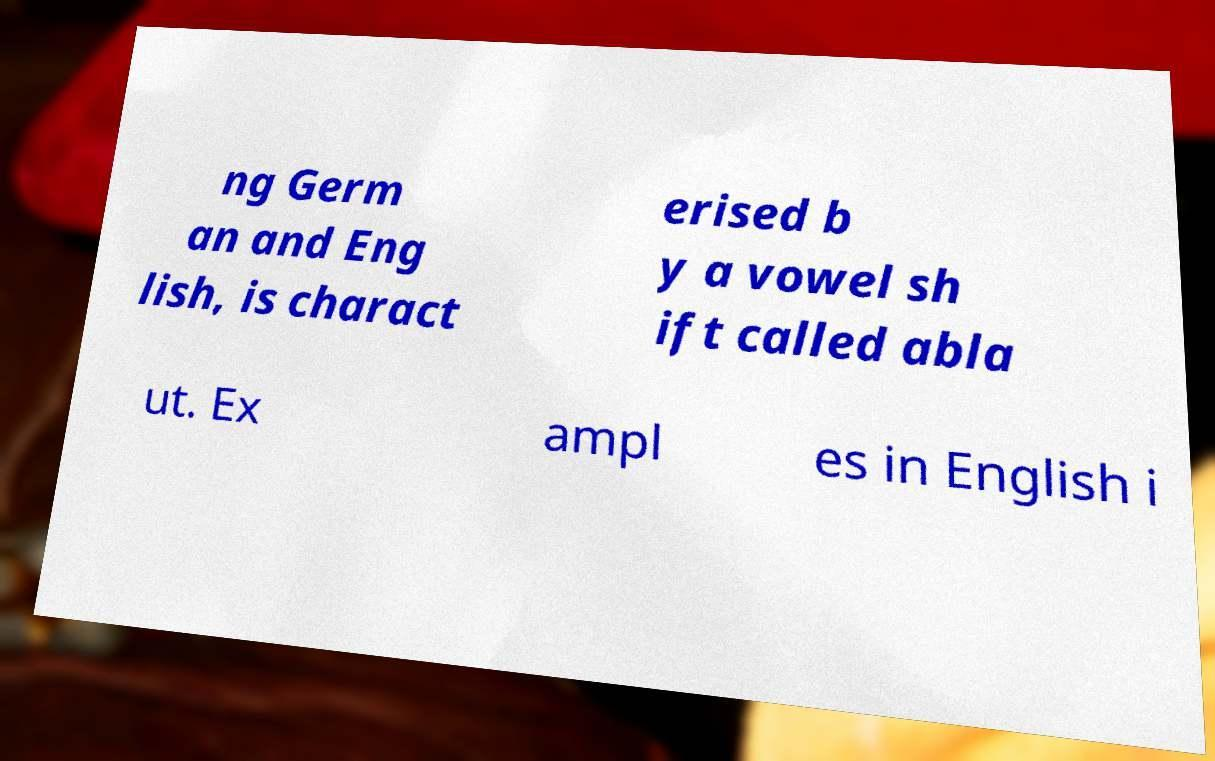Please read and relay the text visible in this image. What does it say? ng Germ an and Eng lish, is charact erised b y a vowel sh ift called abla ut. Ex ampl es in English i 